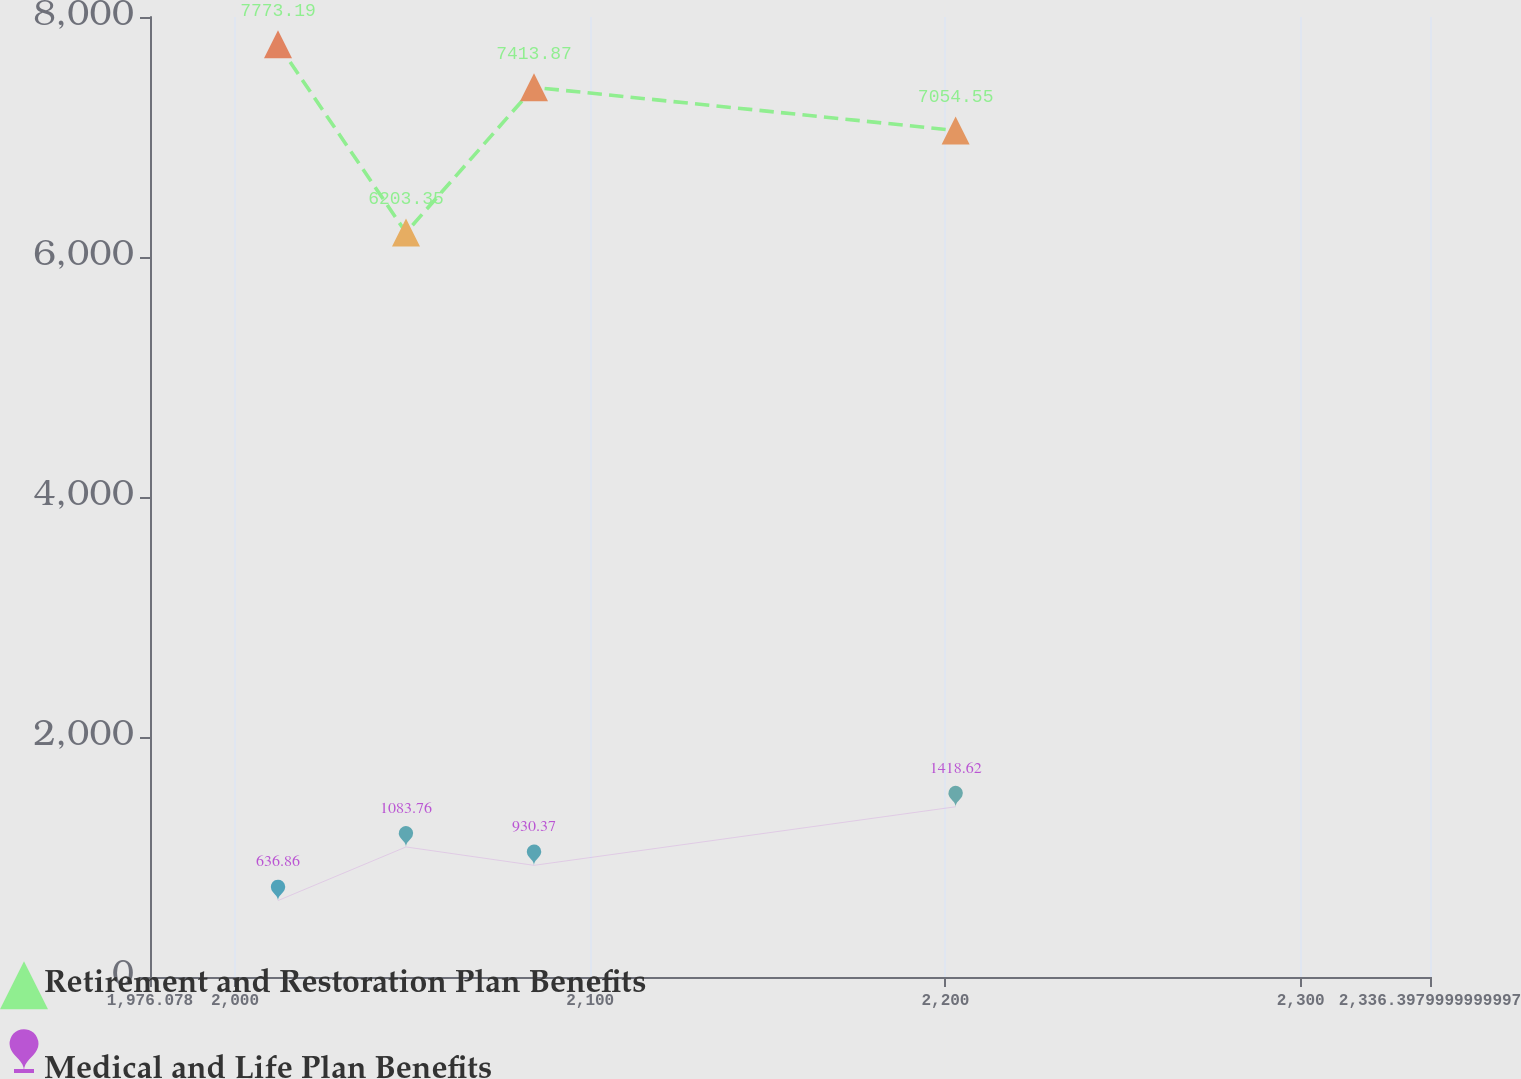Convert chart to OTSL. <chart><loc_0><loc_0><loc_500><loc_500><line_chart><ecel><fcel>Retirement and Restoration Plan Benefits<fcel>Medical and Life Plan Benefits<nl><fcel>2012.11<fcel>7773.19<fcel>636.86<nl><fcel>2048.14<fcel>6203.35<fcel>1083.76<nl><fcel>2084.17<fcel>7413.87<fcel>930.37<nl><fcel>2202.87<fcel>7054.55<fcel>1418.62<nl><fcel>2372.43<fcel>9796.55<fcel>1643.57<nl></chart> 